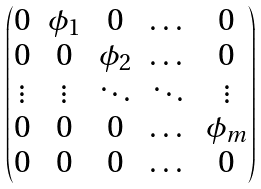Convert formula to latex. <formula><loc_0><loc_0><loc_500><loc_500>\begin{pmatrix} 0 & \phi _ { 1 } & 0 & \dots & 0 \\ 0 & 0 & \phi _ { 2 } & \dots & 0 \\ \vdots & \vdots & \ddots & \ddots & \vdots \\ 0 & 0 & 0 & \dots & \phi _ { m } \\ 0 & 0 & 0 & \dots & 0 \end{pmatrix}</formula> 